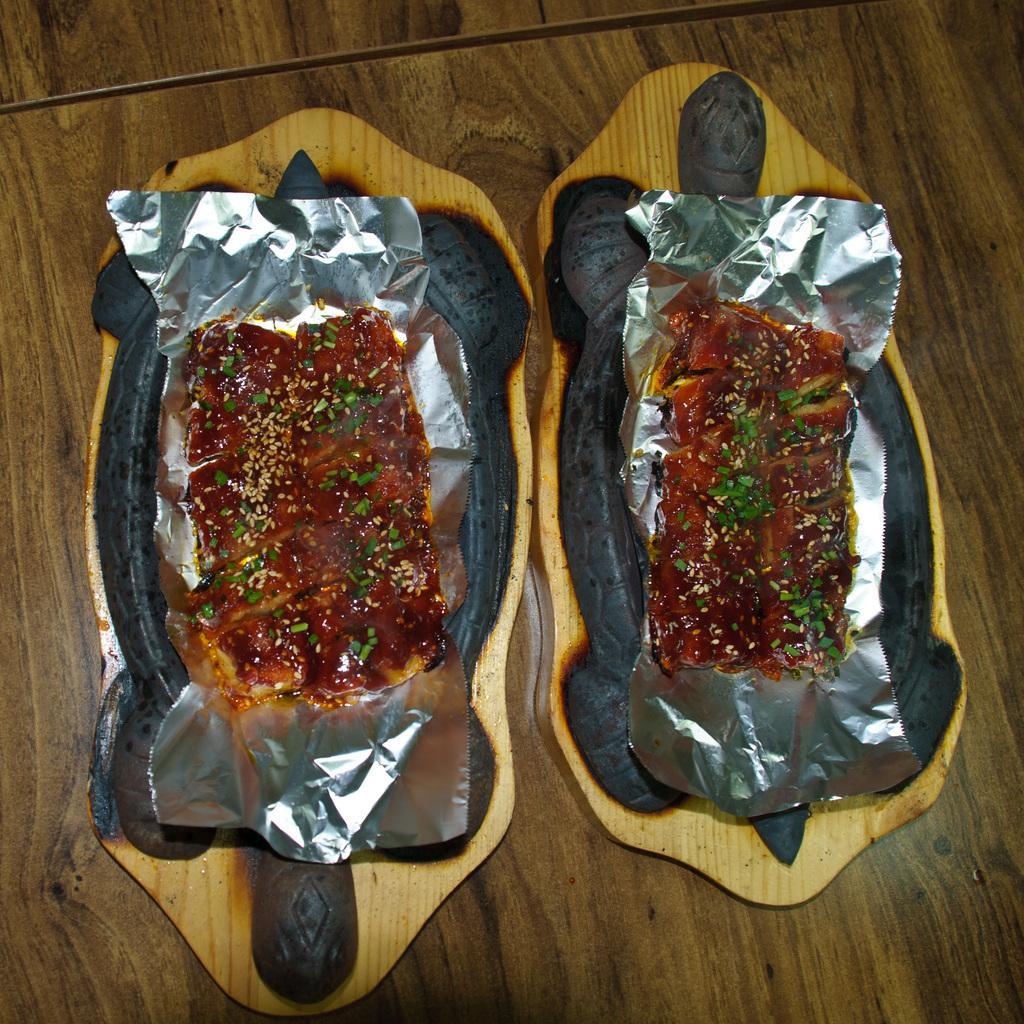Please provide a concise description of this image. In this image we can see some food topped with some grains and peas kept on an aluminium foil in a plate which is placed on the table. 